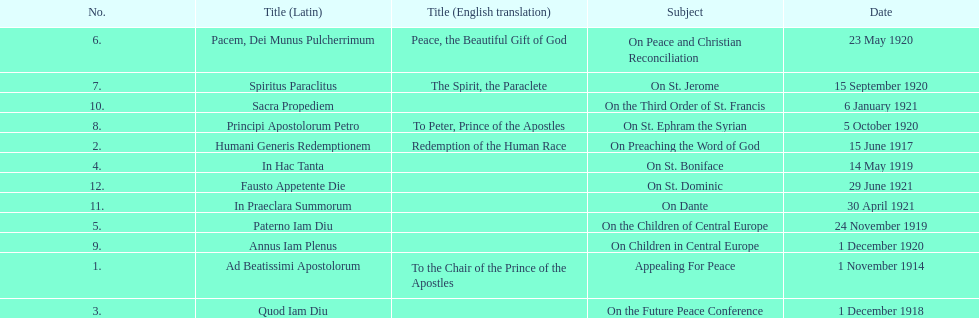How many titles did not list an english translation? 7. 